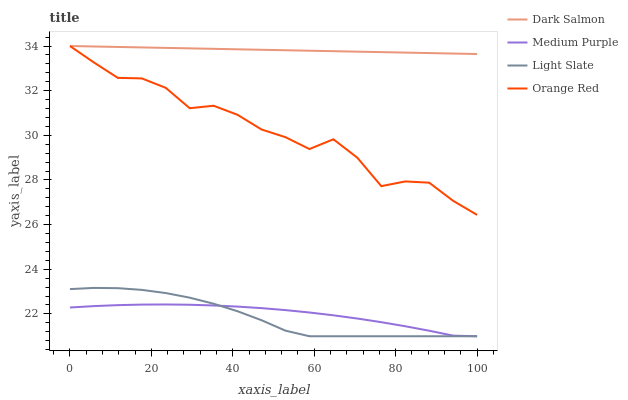Does Light Slate have the minimum area under the curve?
Answer yes or no. Yes. Does Dark Salmon have the maximum area under the curve?
Answer yes or no. Yes. Does Dark Salmon have the minimum area under the curve?
Answer yes or no. No. Does Light Slate have the maximum area under the curve?
Answer yes or no. No. Is Dark Salmon the smoothest?
Answer yes or no. Yes. Is Orange Red the roughest?
Answer yes or no. Yes. Is Light Slate the smoothest?
Answer yes or no. No. Is Light Slate the roughest?
Answer yes or no. No. Does Medium Purple have the lowest value?
Answer yes or no. Yes. Does Dark Salmon have the lowest value?
Answer yes or no. No. Does Orange Red have the highest value?
Answer yes or no. Yes. Does Light Slate have the highest value?
Answer yes or no. No. Is Light Slate less than Orange Red?
Answer yes or no. Yes. Is Orange Red greater than Medium Purple?
Answer yes or no. Yes. Does Dark Salmon intersect Orange Red?
Answer yes or no. Yes. Is Dark Salmon less than Orange Red?
Answer yes or no. No. Is Dark Salmon greater than Orange Red?
Answer yes or no. No. Does Light Slate intersect Orange Red?
Answer yes or no. No. 